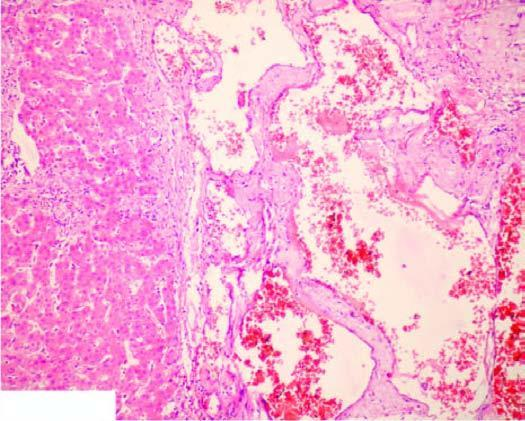s scanty connective tissue stroma seen between the cavernous spaces?
Answer the question using a single word or phrase. Yes 